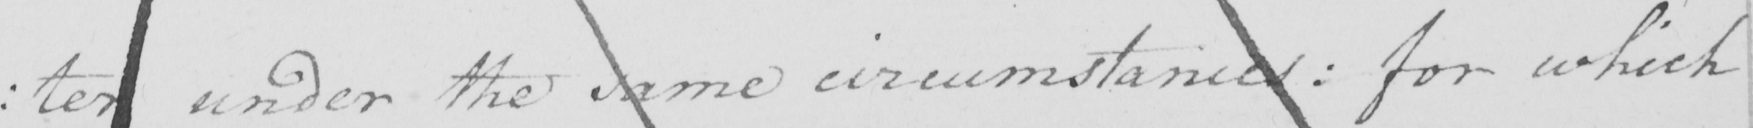Can you read and transcribe this handwriting? : ter under the same circumstances :  for which 